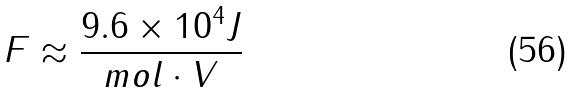Convert formula to latex. <formula><loc_0><loc_0><loc_500><loc_500>F \approx \frac { 9 . 6 \times 1 0 ^ { 4 } J } { m o l \cdot V }</formula> 